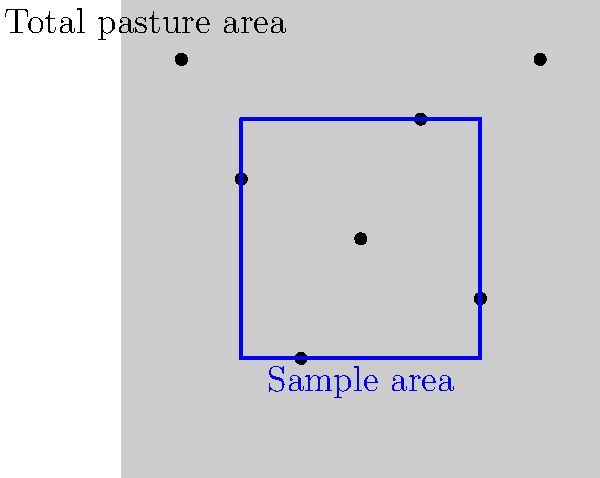You're flying over your ranch to estimate your cattle herd size. The aerial view shows a square pasture that's 1 mile on each side. You count 7 cattle in a sample area that's 1/4 of the total pasture. What's your best estimate of the total herd size? Let's break this down step-by-step:

1. Understand the given information:
   - Total pasture area: 1 mile × 1 mile = 1 square mile
   - Sample area: 1/4 of the total pasture
   - Number of cattle counted in the sample area: 7

2. Calculate the relationship between the sample area and total area:
   - Sample area = 1/4 of total area
   - This means the total area is 4 times the sample area

3. Use the sample to estimate the total herd size:
   - If there are 7 cattle in 1/4 of the area,
   - We can estimate there are 4 times as many in the whole area

4. Perform the calculation:
   $\text{Estimated total herd size} = 7 \text{ cattle} \times 4 = 28 \text{ cattle}$

This method assumes an even distribution of cattle across the pasture, which might not always be the case. But it's a practical way to get a quick estimate from the air.
Answer: 28 cattle 